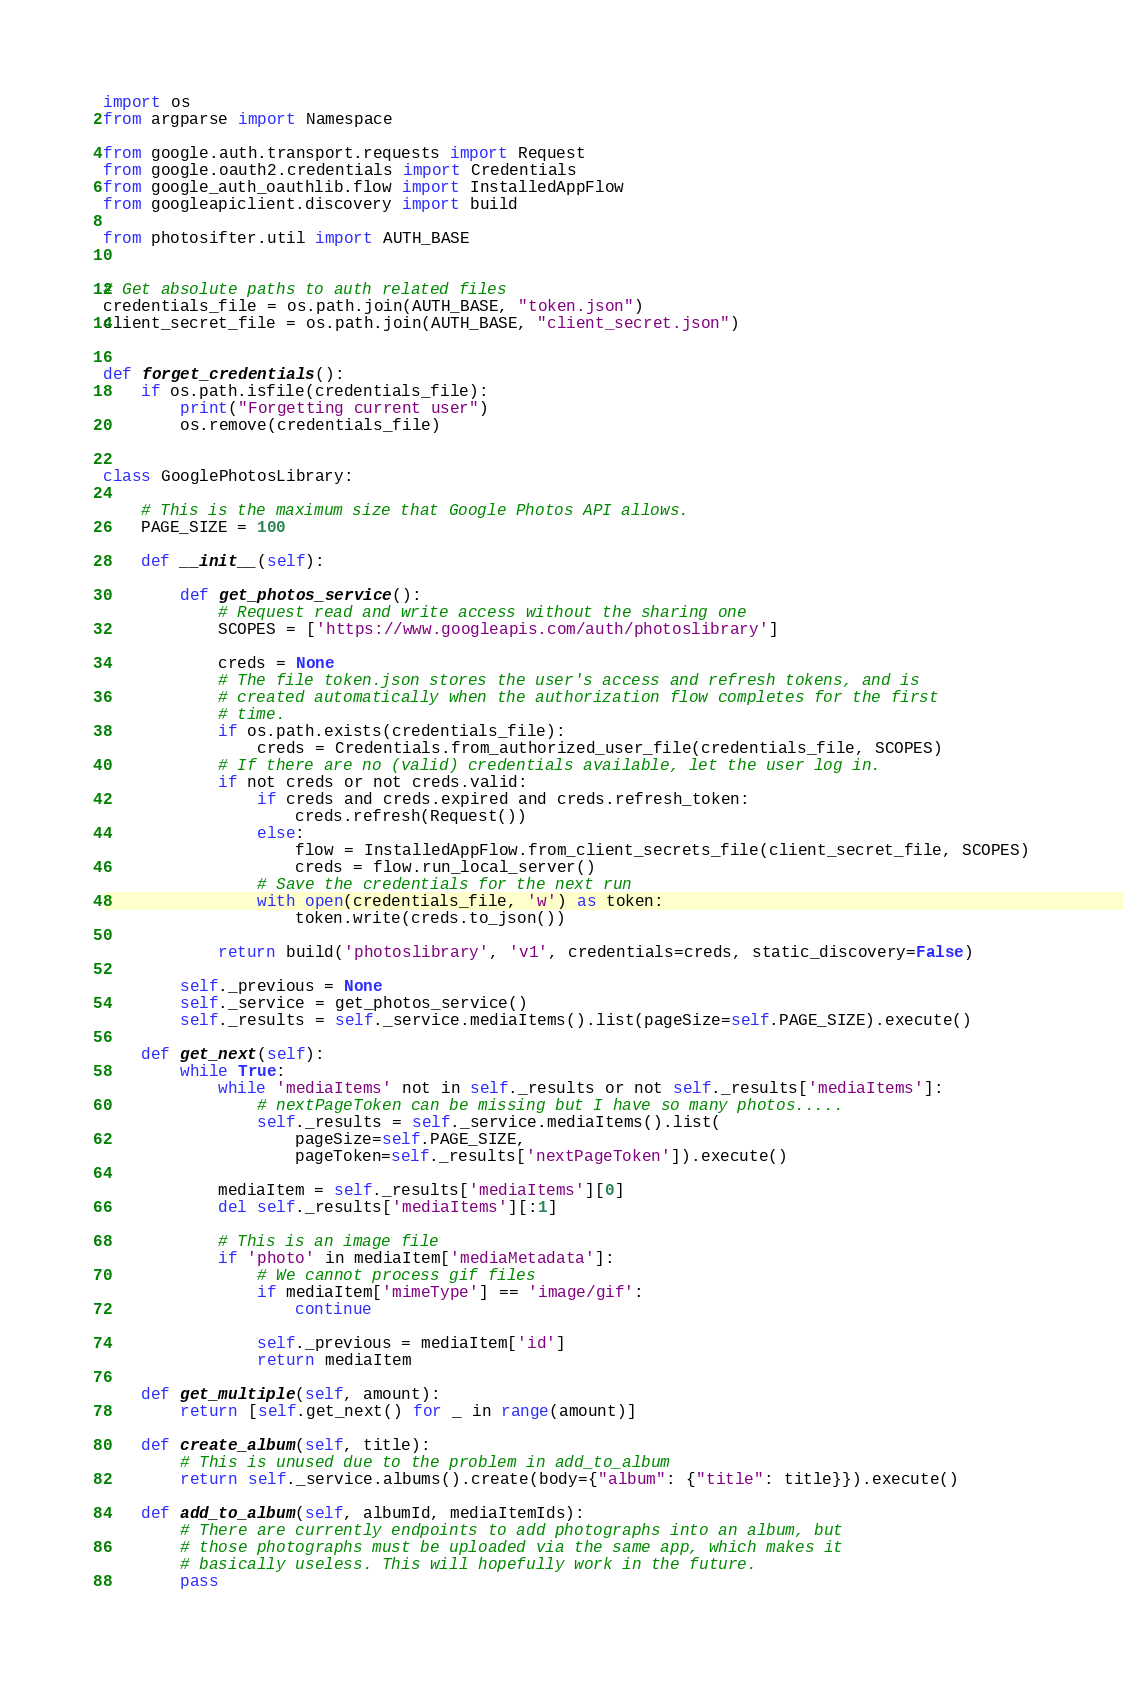Convert code to text. <code><loc_0><loc_0><loc_500><loc_500><_Python_>import os
from argparse import Namespace

from google.auth.transport.requests import Request
from google.oauth2.credentials import Credentials
from google_auth_oauthlib.flow import InstalledAppFlow
from googleapiclient.discovery import build

from photosifter.util import AUTH_BASE


# Get absolute paths to auth related files
credentials_file = os.path.join(AUTH_BASE, "token.json")
client_secret_file = os.path.join(AUTH_BASE, "client_secret.json")


def forget_credentials():
    if os.path.isfile(credentials_file):
        print("Forgetting current user")
        os.remove(credentials_file)


class GooglePhotosLibrary:

    # This is the maximum size that Google Photos API allows.
    PAGE_SIZE = 100

    def __init__(self):

        def get_photos_service():
            # Request read and write access without the sharing one
            SCOPES = ['https://www.googleapis.com/auth/photoslibrary']

            creds = None
            # The file token.json stores the user's access and refresh tokens, and is
            # created automatically when the authorization flow completes for the first
            # time.
            if os.path.exists(credentials_file):
                creds = Credentials.from_authorized_user_file(credentials_file, SCOPES)
            # If there are no (valid) credentials available, let the user log in.
            if not creds or not creds.valid:
                if creds and creds.expired and creds.refresh_token:
                    creds.refresh(Request())
                else:
                    flow = InstalledAppFlow.from_client_secrets_file(client_secret_file, SCOPES)
                    creds = flow.run_local_server()
                # Save the credentials for the next run
                with open(credentials_file, 'w') as token:
                    token.write(creds.to_json())

            return build('photoslibrary', 'v1', credentials=creds, static_discovery=False)

        self._previous = None
        self._service = get_photos_service()
        self._results = self._service.mediaItems().list(pageSize=self.PAGE_SIZE).execute()

    def get_next(self):
        while True:
            while 'mediaItems' not in self._results or not self._results['mediaItems']:
                # nextPageToken can be missing but I have so many photos.....
                self._results = self._service.mediaItems().list(
                    pageSize=self.PAGE_SIZE,
                    pageToken=self._results['nextPageToken']).execute()

            mediaItem = self._results['mediaItems'][0]
            del self._results['mediaItems'][:1]

            # This is an image file
            if 'photo' in mediaItem['mediaMetadata']:
                # We cannot process gif files
                if mediaItem['mimeType'] == 'image/gif':
                    continue

                self._previous = mediaItem['id']
                return mediaItem

    def get_multiple(self, amount):
        return [self.get_next() for _ in range(amount)]

    def create_album(self, title):
        # This is unused due to the problem in add_to_album
        return self._service.albums().create(body={"album": {"title": title}}).execute()

    def add_to_album(self, albumId, mediaItemIds):
        # There are currently endpoints to add photographs into an album, but
        # those photographs must be uploaded via the same app, which makes it
        # basically useless. This will hopefully work in the future.
        pass
</code> 